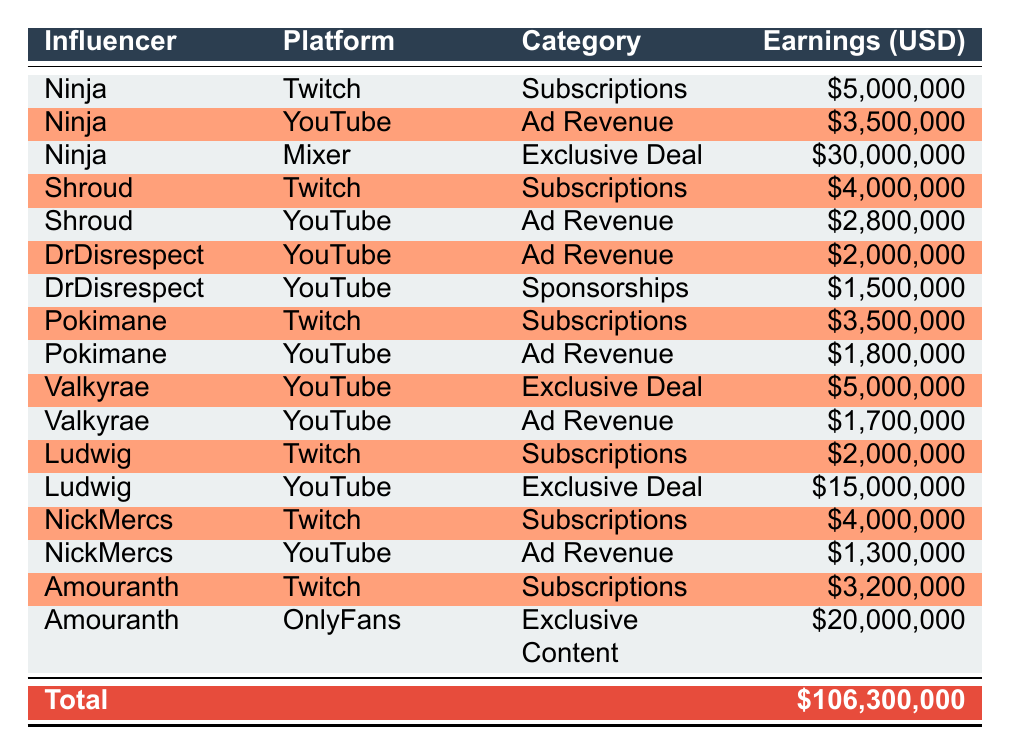What's the highest earning category for Ninja? Ninja earned the most from the Mixer platform under the category "Exclusive Deal" with earnings of 30,000,000 USD, which is higher than his earnings on Twitch and YouTube.
Answer: Exclusive Deal What are the total earnings of Shroud in 2022? Shroud's earnings consist of 4,000,000 USD (Twitch Subscriptions) and 2,800,000 USD (YouTube Ad Revenue), summing them gives 6,800,000 USD.
Answer: 6,800,000 USD Did Amouranth earn more from Twitch subscriptions or OnlyFans exclusive content? Amouranth earned 3,200,000 USD from Twitch subscriptions and 20,000,000 USD from OnlyFans exclusive content, which is higher, therefore the statement is true.
Answer: Yes What is the total amount earned by all influencers from YouTube? The earnings from YouTube across all influencers are as follows: Ninja (3,500,000), Shroud (2,800,000), DrDisrespect (2,000,000 + 1,500,000), Pokimane (1,800,000), Valkyrae (1,700,000), Ludwig (15,000,000), NickMercs (1,300,000). Summing these totals gives a final amount of 29,600,000 USD.
Answer: 29,600,000 USD How much more did Ninja earn than Pokimane in total? Calculating Ninja's total earnings, 5,000,000 (Twitch) + 3,500,000 (YouTube) + 30,000,000 (Mixer) equals 38,500,000 USD. Pokimane earned 3,500,000 (Twitch) + 1,800,000 (YouTube) totaling 5,300,000 USD. The difference between Ninja's and Pokimane's earnings is 38,500,000 - 5,300,000 = 33,200,000 USD.
Answer: 33,200,000 USD Is Shroud's total earning from subscriptions greater than Amouranth's total earnings from subscriptions? Shroud earned 4,000,000 USD from Twitch subscriptions while Amouranth earned 3,200,000 USD from Twitch subscriptions. Since 4,000,000 is more than 3,200,000, the statement is true.
Answer: Yes 